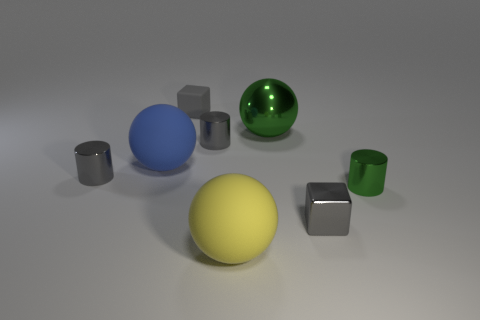What is the small gray block that is behind the large blue thing made of?
Offer a very short reply. Rubber. Are there an equal number of small metal objects that are behind the large green metal sphere and large gray matte blocks?
Your answer should be compact. Yes. Is the green sphere the same size as the green cylinder?
Provide a succinct answer. No. There is a small gray metallic cylinder in front of the big object to the left of the tiny rubber thing; is there a big matte object that is left of it?
Offer a very short reply. No. There is a large yellow thing that is the same shape as the blue matte thing; what is it made of?
Your answer should be compact. Rubber. What number of gray objects are behind the gray cylinder that is behind the big blue rubber sphere?
Offer a very short reply. 1. What size is the sphere behind the small shiny thing behind the big rubber object that is to the left of the tiny matte thing?
Make the answer very short. Large. What is the color of the matte ball on the left side of the block behind the small green metallic object?
Your answer should be compact. Blue. How many other objects are the same material as the big green sphere?
Make the answer very short. 4. What number of other things are there of the same color as the rubber cube?
Ensure brevity in your answer.  3. 